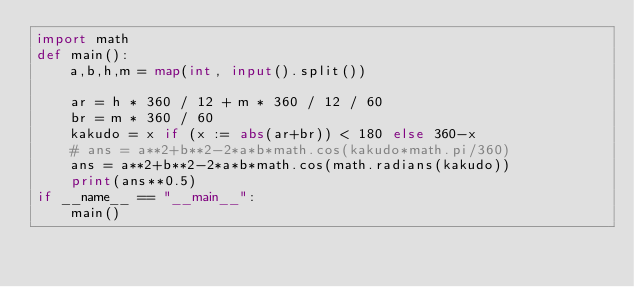<code> <loc_0><loc_0><loc_500><loc_500><_Python_>import math
def main():
    a,b,h,m = map(int, input().split())
 
    ar = h * 360 / 12 + m * 360 / 12 / 60
    br = m * 360 / 60
    kakudo = x if (x := abs(ar+br)) < 180 else 360-x
    # ans = a**2+b**2-2*a*b*math.cos(kakudo*math.pi/360)
    ans = a**2+b**2-2*a*b*math.cos(math.radians(kakudo))
    print(ans**0.5)
if __name__ == "__main__":
    main()</code> 